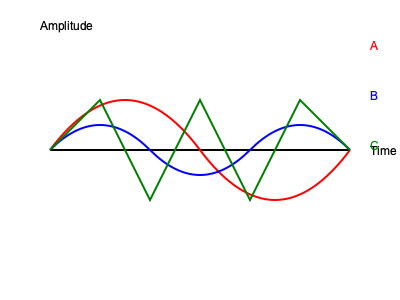As a music producer familiar with various instruments, which of the sound wave patterns (A, B, or C) most likely represents a flute? To identify the sound wave pattern of a flute, let's analyze each waveform:

1. Waveform A (red): This is a simple sine wave, characterized by its smooth, regular oscillation. It represents a pure tone with a single frequency, which is rare in natural instruments.

2. Waveform B (blue): This pattern shows a more complex wave with rounded peaks and troughs. It's closer to a natural instrument sound, with some harmonics present, but still relatively simple.

3. Waveform C (green): This is a sawtooth wave, characterized by sharp rises and falls. It's typically associated with electronic or synthesized sounds, or instruments with a very bright, harsh tone.

The flute, being a wind instrument, produces a tone that is relatively pure but still contains some harmonics. Its sound wave is closest to a sine wave but with some additional complexity.

Step-by-step analysis:
1. Eliminate waveform C, as it's too harsh for a flute's mellow sound.
2. Compare waveforms A and B.
3. While A is very pure, B shows some complexity that better represents a real instrument.
4. The rounded nature of waveform B closely matches the flute's smooth, airy quality.

Therefore, waveform B most accurately represents the sound wave pattern of a flute.
Answer: B 